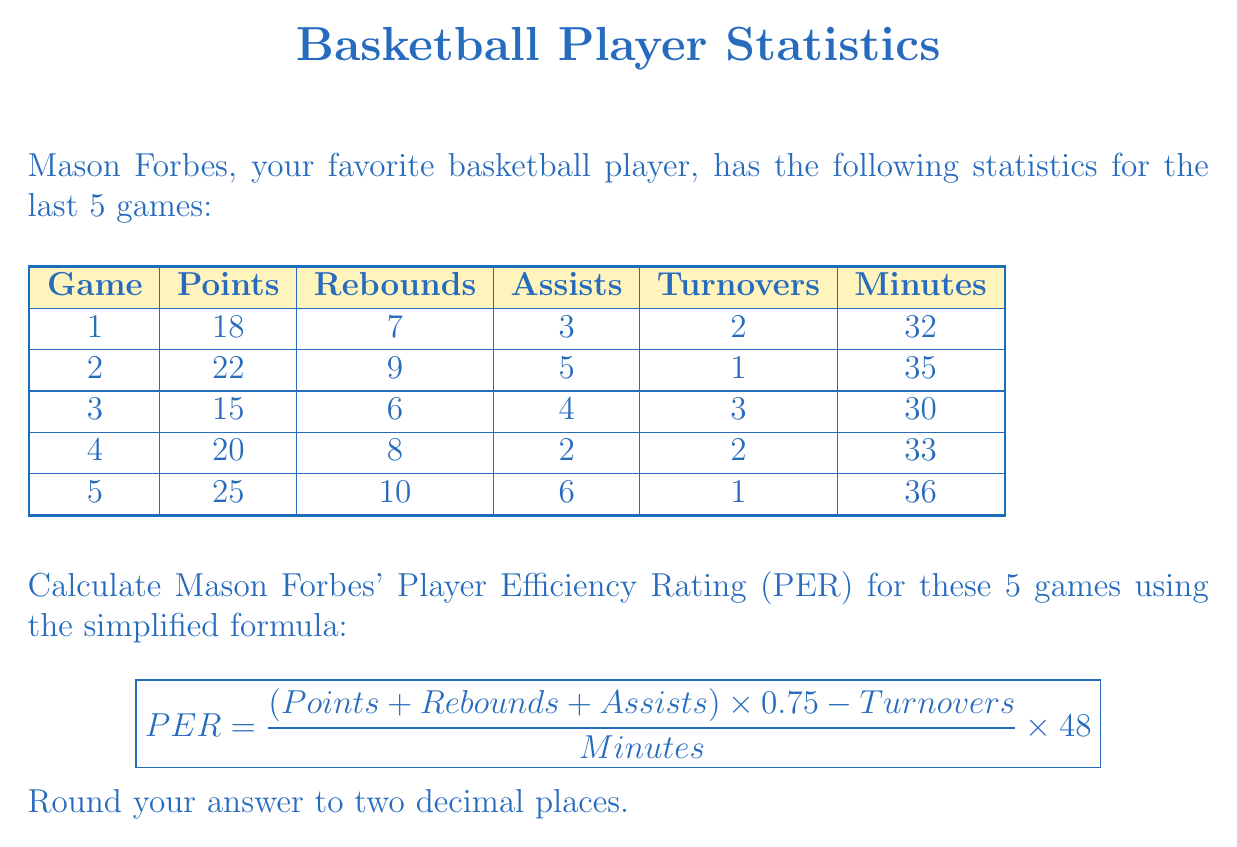Could you help me with this problem? To calculate Mason Forbes' PER, we'll follow these steps:

1. Calculate the total points, rebounds, assists, turnovers, and minutes for all 5 games.
2. Apply the given formula.
3. Round the result to two decimal places.

Step 1: Totals
* Total Points: $18 + 22 + 15 + 20 + 25 = 100$
* Total Rebounds: $7 + 9 + 6 + 8 + 10 = 40$
* Total Assists: $3 + 5 + 4 + 2 + 6 = 20$
* Total Turnovers: $2 + 1 + 3 + 2 + 1 = 9$
* Total Minutes: $32 + 35 + 30 + 33 + 36 = 166$

Step 2: Apply the formula
$$ PER = \frac{(100 + 40 + 20) \times 0.75 - 9}{166} \times 48 $$

$$ PER = \frac{160 \times 0.75 - 9}{166} \times 48 $$

$$ PER = \frac{120 - 9}{166} \times 48 $$

$$ PER = \frac{111}{166} \times 48 $$

$$ PER = 0.6686746988 \times 48 $$

$$ PER = 32.09638554 $$

Step 3: Round to two decimal places
$$ PER \approx 32.10 $$
Answer: 32.10 